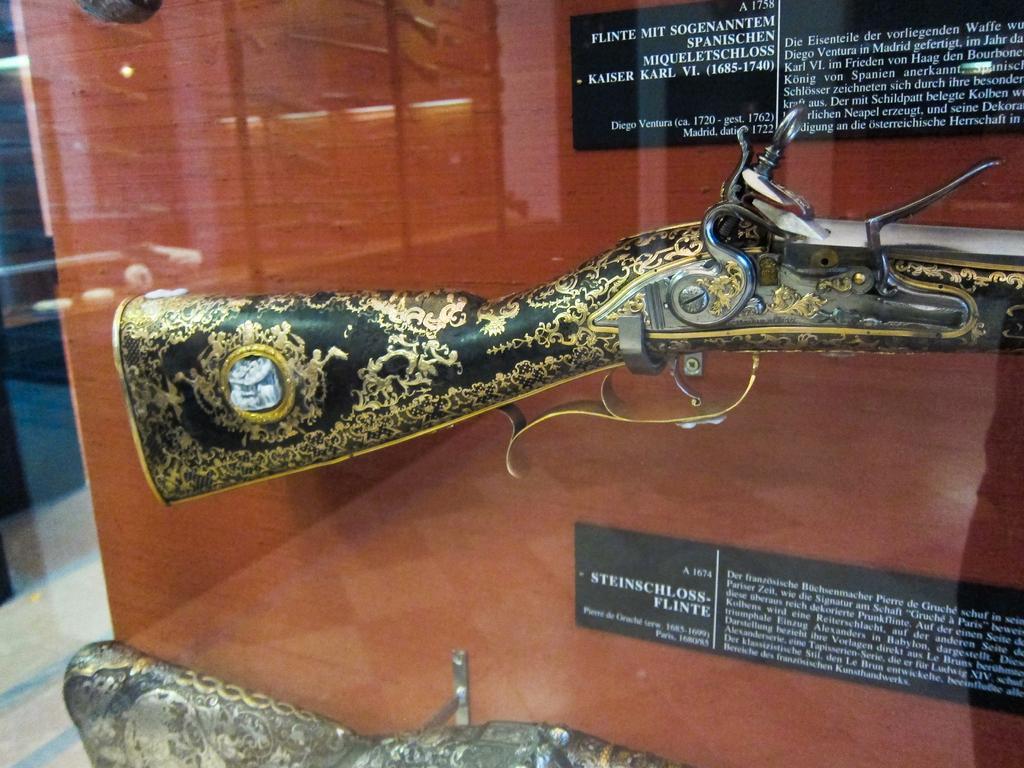How would you summarize this image in a sentence or two? In the center of this picture we can see a rifle and in the foreground there is an object seems to be the riffle and we can see the black color boards on which the text is printed. In the background there is a wooden cabinet and the ground. 